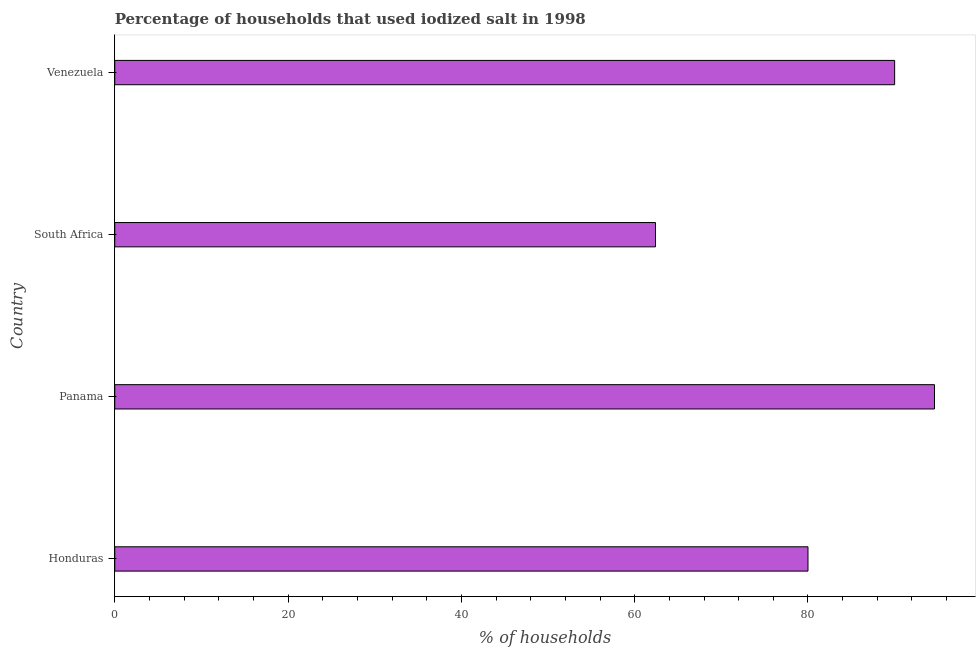What is the title of the graph?
Ensure brevity in your answer.  Percentage of households that used iodized salt in 1998. What is the label or title of the X-axis?
Make the answer very short. % of households. What is the label or title of the Y-axis?
Make the answer very short. Country. Across all countries, what is the maximum percentage of households where iodized salt is consumed?
Your answer should be compact. 94.6. Across all countries, what is the minimum percentage of households where iodized salt is consumed?
Make the answer very short. 62.4. In which country was the percentage of households where iodized salt is consumed maximum?
Provide a short and direct response. Panama. In which country was the percentage of households where iodized salt is consumed minimum?
Provide a succinct answer. South Africa. What is the sum of the percentage of households where iodized salt is consumed?
Your answer should be very brief. 327. What is the difference between the percentage of households where iodized salt is consumed in Honduras and South Africa?
Give a very brief answer. 17.6. What is the average percentage of households where iodized salt is consumed per country?
Your response must be concise. 81.75. In how many countries, is the percentage of households where iodized salt is consumed greater than 84 %?
Provide a short and direct response. 2. What is the ratio of the percentage of households where iodized salt is consumed in Honduras to that in Venezuela?
Provide a short and direct response. 0.89. What is the difference between the highest and the second highest percentage of households where iodized salt is consumed?
Your response must be concise. 4.6. What is the difference between the highest and the lowest percentage of households where iodized salt is consumed?
Your answer should be very brief. 32.2. How many countries are there in the graph?
Ensure brevity in your answer.  4. What is the % of households of Panama?
Your answer should be very brief. 94.6. What is the % of households of South Africa?
Make the answer very short. 62.4. What is the difference between the % of households in Honduras and Panama?
Keep it short and to the point. -14.6. What is the difference between the % of households in Honduras and Venezuela?
Your response must be concise. -10. What is the difference between the % of households in Panama and South Africa?
Provide a succinct answer. 32.2. What is the difference between the % of households in South Africa and Venezuela?
Provide a short and direct response. -27.6. What is the ratio of the % of households in Honduras to that in Panama?
Provide a succinct answer. 0.85. What is the ratio of the % of households in Honduras to that in South Africa?
Ensure brevity in your answer.  1.28. What is the ratio of the % of households in Honduras to that in Venezuela?
Make the answer very short. 0.89. What is the ratio of the % of households in Panama to that in South Africa?
Give a very brief answer. 1.52. What is the ratio of the % of households in Panama to that in Venezuela?
Make the answer very short. 1.05. What is the ratio of the % of households in South Africa to that in Venezuela?
Give a very brief answer. 0.69. 